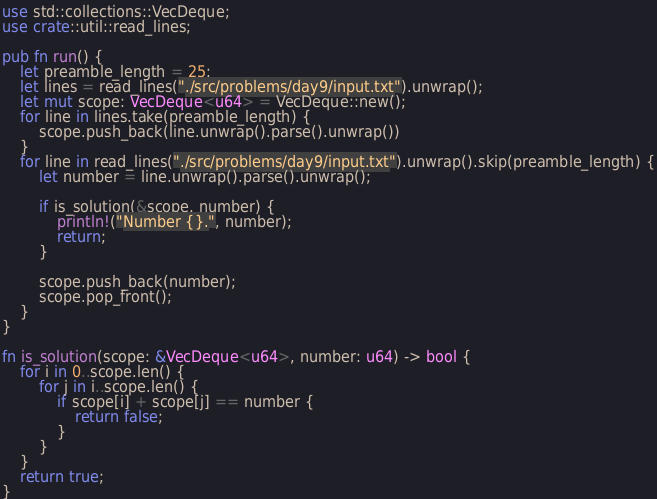Convert code to text. <code><loc_0><loc_0><loc_500><loc_500><_Rust_>
use std::collections::VecDeque;
use crate::util::read_lines;

pub fn run() {
    let preamble_length = 25;
    let lines = read_lines("./src/problems/day9/input.txt").unwrap();
    let mut scope: VecDeque<u64> = VecDeque::new();
    for line in lines.take(preamble_length) {
        scope.push_back(line.unwrap().parse().unwrap())
    }
    for line in read_lines("./src/problems/day9/input.txt").unwrap().skip(preamble_length) {
        let number = line.unwrap().parse().unwrap();
        
        if is_solution(&scope, number) {
            println!("Number {}.", number);
            return;
        }

        scope.push_back(number);
        scope.pop_front();
    }
}

fn is_solution(scope: &VecDeque<u64>, number: u64) -> bool {
    for i in 0..scope.len() {
        for j in i..scope.len() {
            if scope[i] + scope[j] == number {
                return false;
            }
        }
    }
    return true;
}</code> 